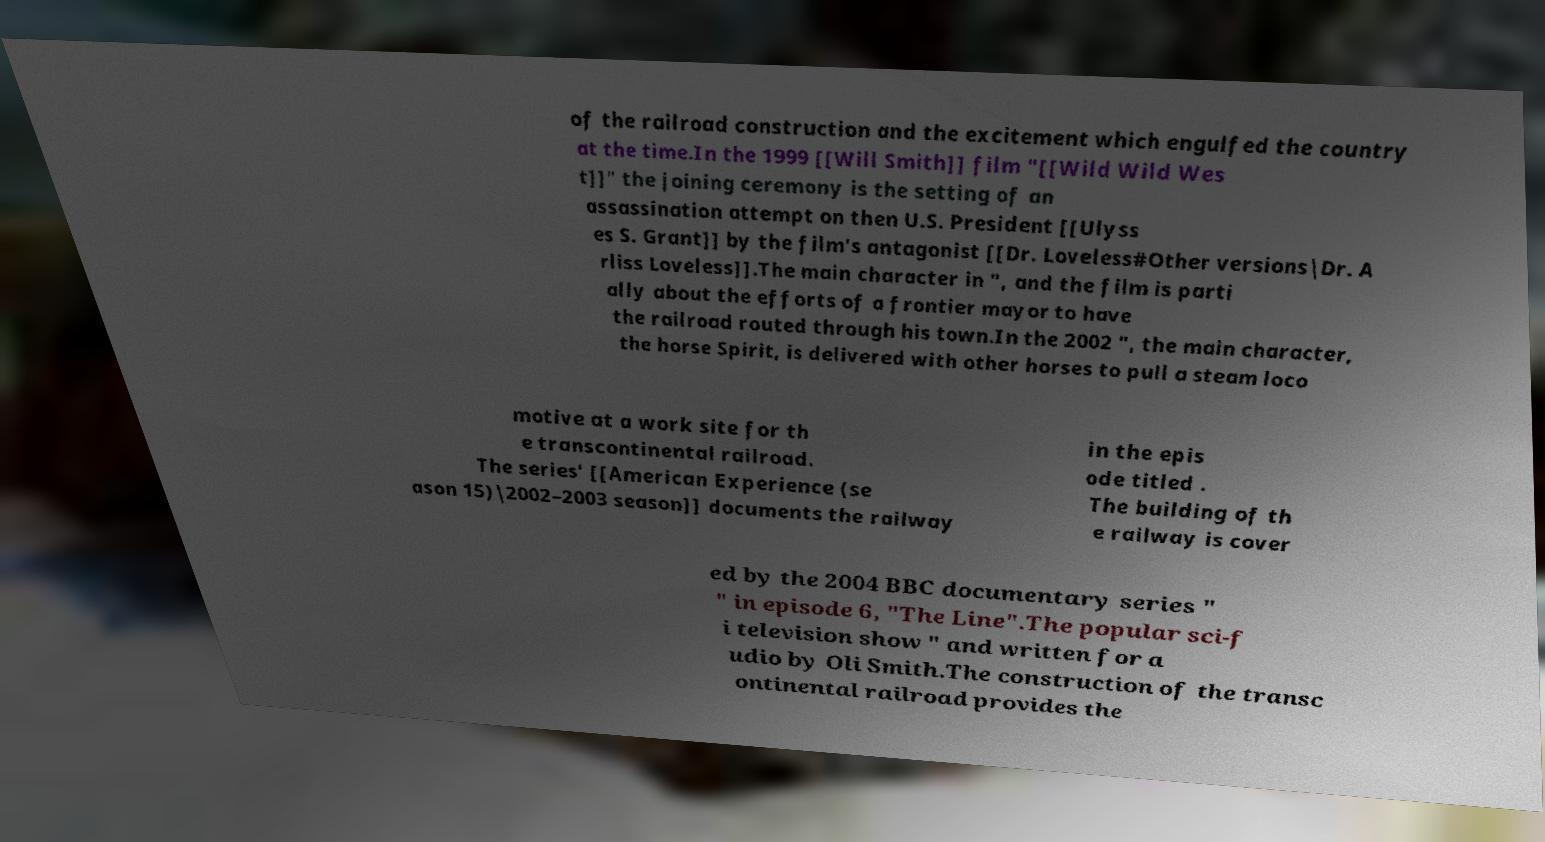Could you extract and type out the text from this image? of the railroad construction and the excitement which engulfed the country at the time.In the 1999 [[Will Smith]] film "[[Wild Wild Wes t]]" the joining ceremony is the setting of an assassination attempt on then U.S. President [[Ulyss es S. Grant]] by the film's antagonist [[Dr. Loveless#Other versions|Dr. A rliss Loveless]].The main character in ", and the film is parti ally about the efforts of a frontier mayor to have the railroad routed through his town.In the 2002 ", the main character, the horse Spirit, is delivered with other horses to pull a steam loco motive at a work site for th e transcontinental railroad. The series' [[American Experience (se ason 15)|2002–2003 season]] documents the railway in the epis ode titled . The building of th e railway is cover ed by the 2004 BBC documentary series " " in episode 6, "The Line".The popular sci-f i television show " and written for a udio by Oli Smith.The construction of the transc ontinental railroad provides the 